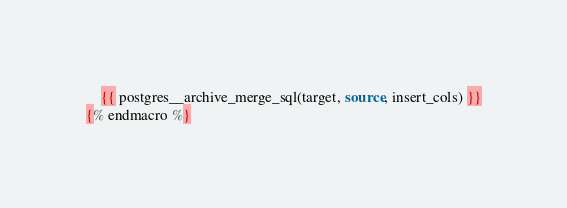<code> <loc_0><loc_0><loc_500><loc_500><_SQL_>    {{ postgres__archive_merge_sql(target, source, insert_cols) }}
{% endmacro %}
</code> 